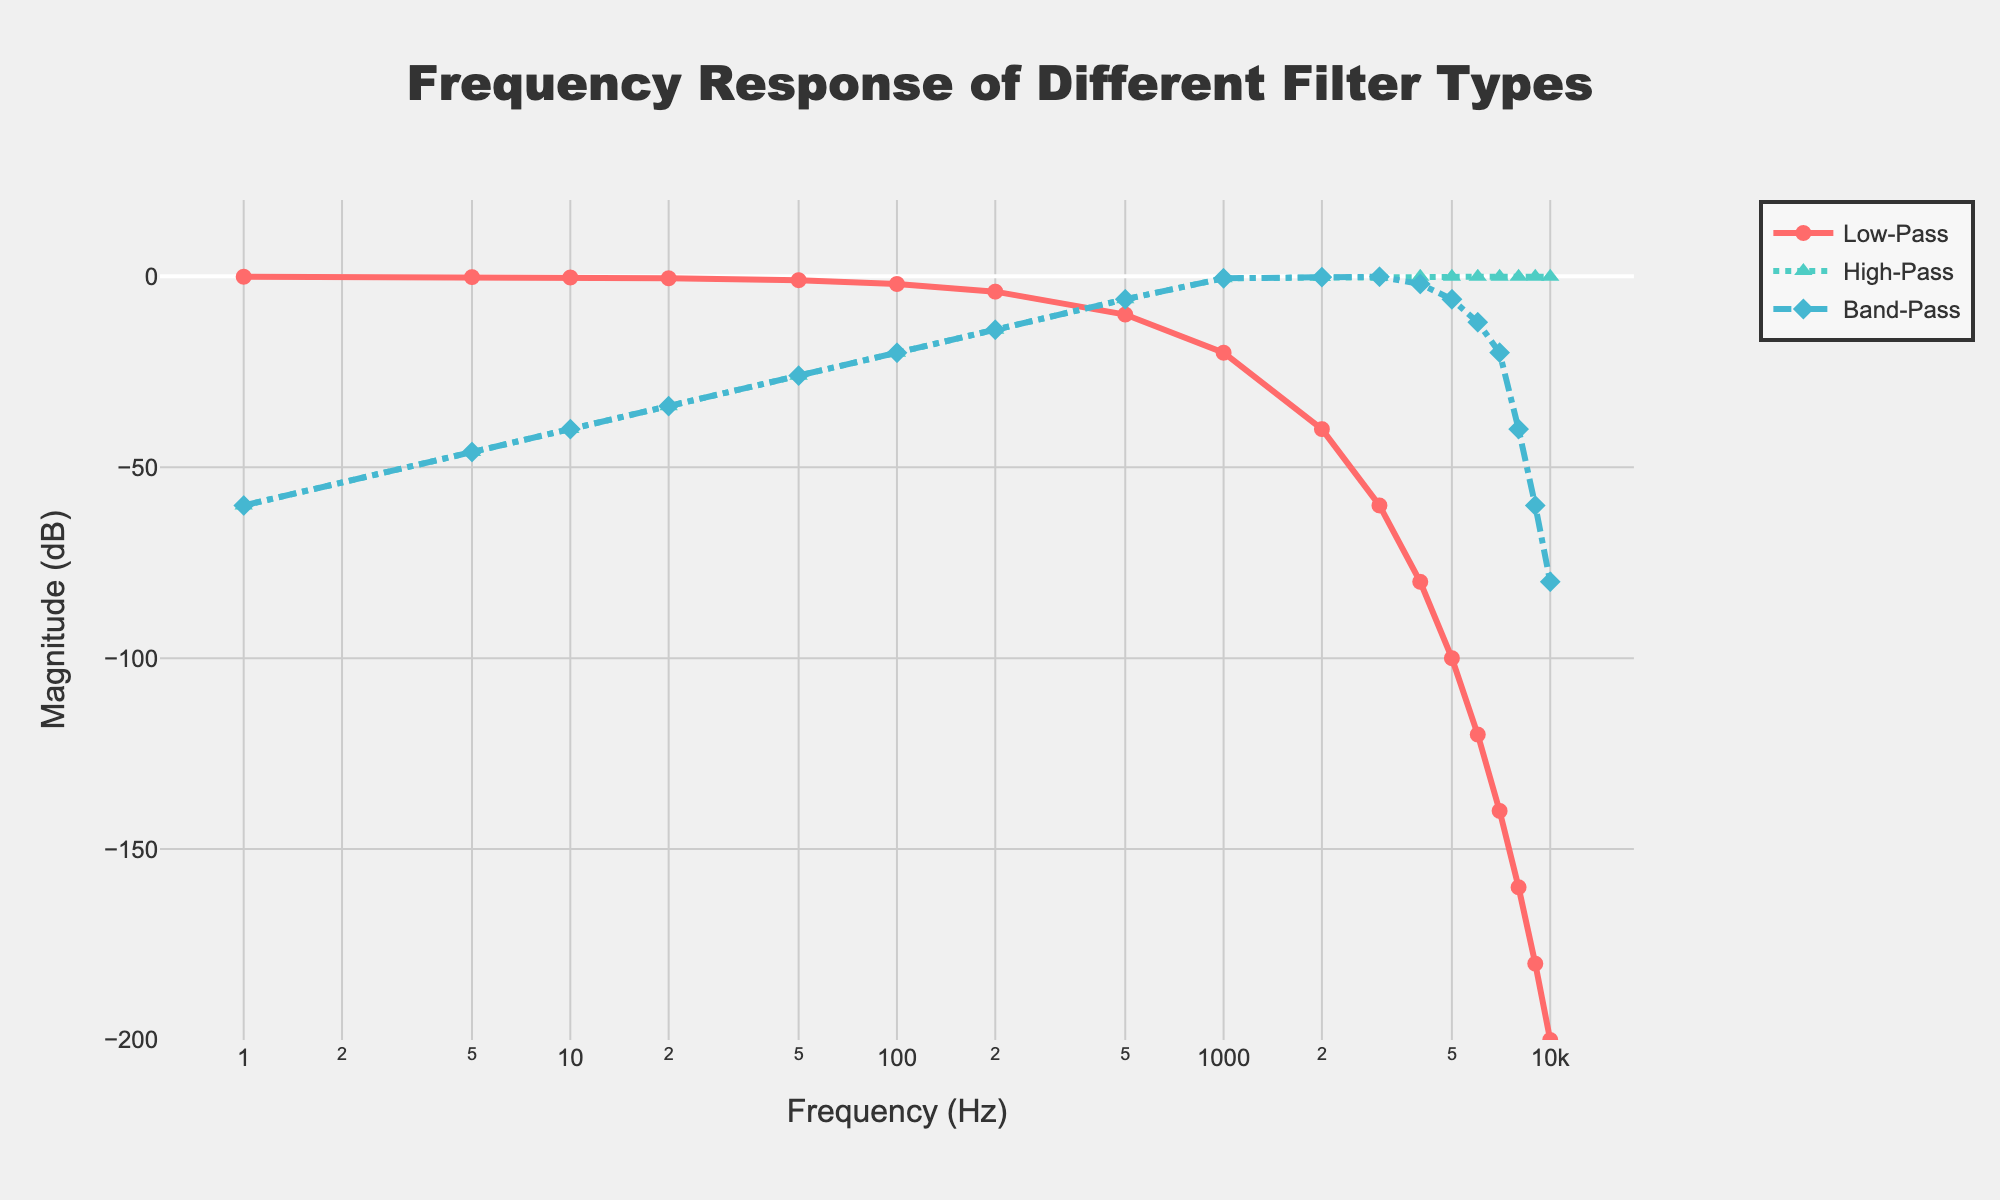What is the initial magnitude of the Low-Pass filter at 1 Hz? To determine the initial magnitude, look at the dB value for the Low-Pass filter at the frequency of 1 Hz on the x-axis. The magnitude is given as -0.1 dB.
Answer: -0.1 dB Which filter has the steepest drop-off in magnitude as the frequency increases from 500 Hz to 1000 Hz? Compare the dB values for each filter type at 500 Hz and 1000 Hz. Low-Pass drops from -10.0 dB to -20.0 dB (a change of -10 dB), High-Pass drops from -6.0 dB to -0.5 dB (a change of 5.5 dB), and Band-Pass drops from -6.0 dB to -0.5 dB (a change of 5.5 dB). The Low-Pass filter has the steepest drop.
Answer: Low-Pass At which frequency does the Band-Pass filter's magnitude first reach -40 dB? Look at the data for the Band-Pass filter to find the first frequency where the magnitude is -40 dB. This occurs at 8000 Hz.
Answer: 8000 Hz Which filter type maintains its magnitude closest to 0 dB for the highest number of frequency points between 1 Hz and 10000 Hz? Examine all points in the given frequency range and observe which filter's magnitude remains closest to 0 dB. The High-Pass filter maintains its magnitude closest to 0 dB through most of the frequencies.
Answer: High-Pass What is the difference in magnitude between the Low-Pass and High-Pass filters at 100 Hz? Check the magnitude values for both filters at 100 Hz. Low-Pass is -2.0 dB and High-Pass is -20.0 dB. The difference is -2.0 - (-20.0) = 18 dB.
Answer: 18 dB How many filters have a magnitude below -100 dB at 10000 Hz? Look at the magnitude values for each filter type at 10000 Hz. Only the Low-Pass filter has a magnitude below -100 dB, with a value of -200 dB.
Answer: 1 What is the relative ranking of the magnitudes of the filters at 200 Hz? List the magnitudes of the filters at 200 Hz and rank them. Low-Pass is -4.0 dB, High-Pass is -14.0 dB, and Band-Pass is -14.0 dB. The ranking from least to greatest is High-Pass/Band-Pass (tie), then Low-Pass.
Answer: High-Pass/Band-Pass, Low-Pass At what frequency do the High-Pass and Band-Pass filters have the same magnitude first? Compare the magnitudes of High-Pass and Band-Pass filters across the frequency range and find the first frequency where they have the same value. These filters have the same magnitude for the first time at 1 Hz, where both are -60.0 dB.
Answer: 1 Hz 